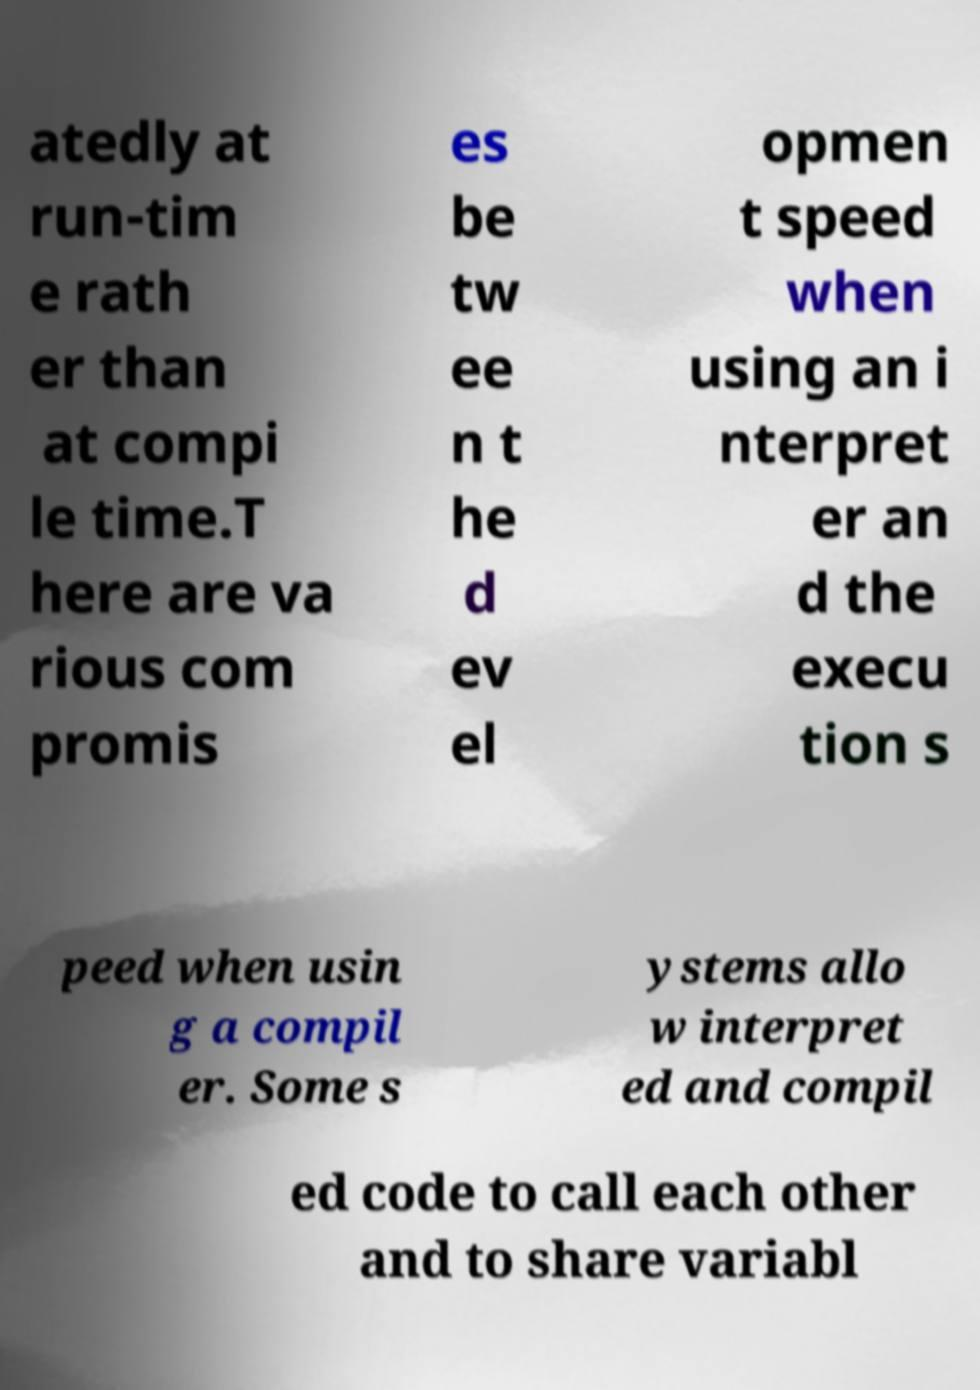There's text embedded in this image that I need extracted. Can you transcribe it verbatim? atedly at run-tim e rath er than at compi le time.T here are va rious com promis es be tw ee n t he d ev el opmen t speed when using an i nterpret er an d the execu tion s peed when usin g a compil er. Some s ystems allo w interpret ed and compil ed code to call each other and to share variabl 